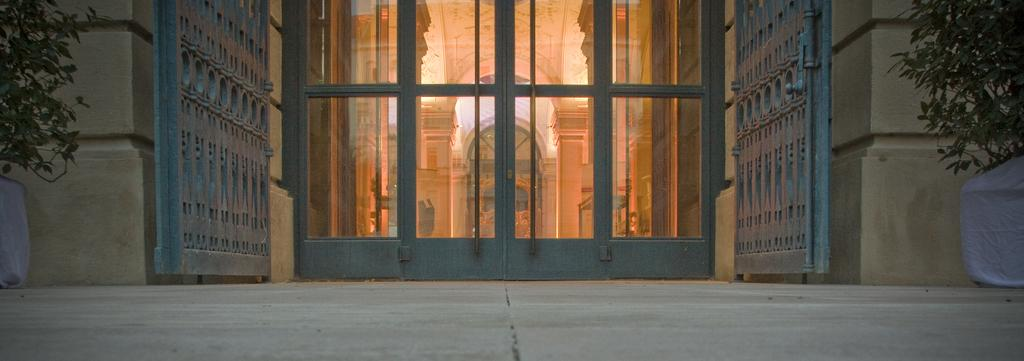What type of living organisms can be seen in the image? Plants can be seen in the image. What is visible behind the plants in the image? There is a building behind the plants in the image. What type of scissors can be seen cutting the plants in the image? There are no scissors present in the image, and the plants are not being cut. What type of plane can be seen flying over the plants in the image? There is no plane visible in the image; it only features plants and a building in the background. 